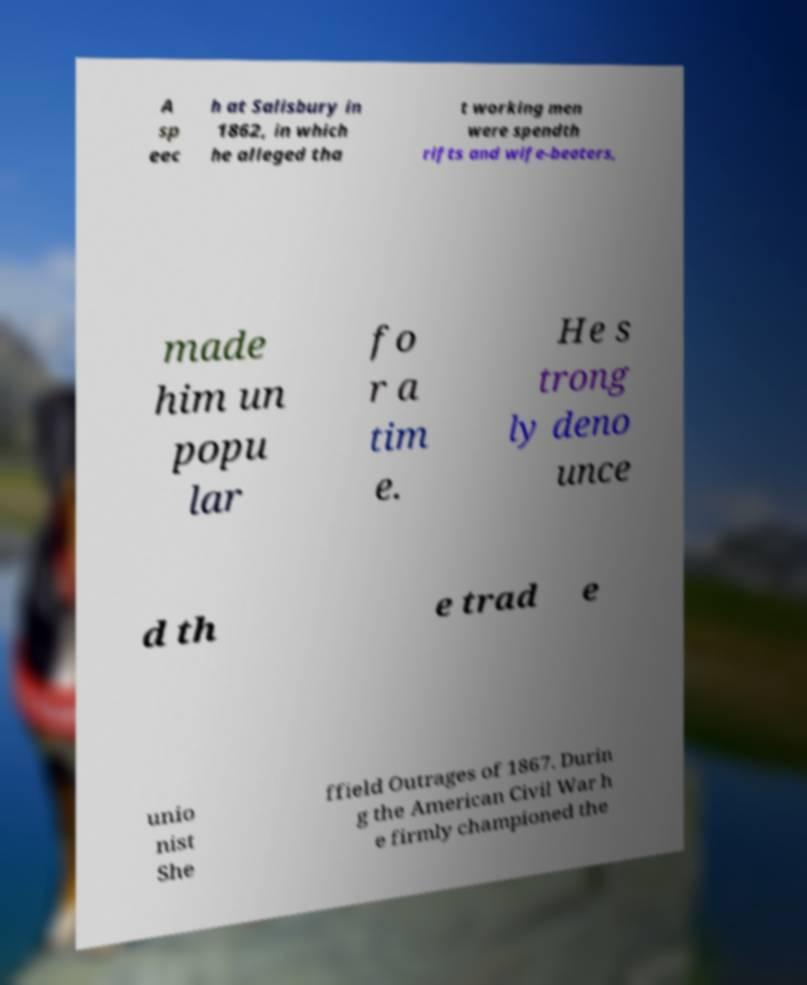I need the written content from this picture converted into text. Can you do that? A sp eec h at Salisbury in 1862, in which he alleged tha t working men were spendth rifts and wife-beaters, made him un popu lar fo r a tim e. He s trong ly deno unce d th e trad e unio nist She ffield Outrages of 1867. Durin g the American Civil War h e firmly championed the 